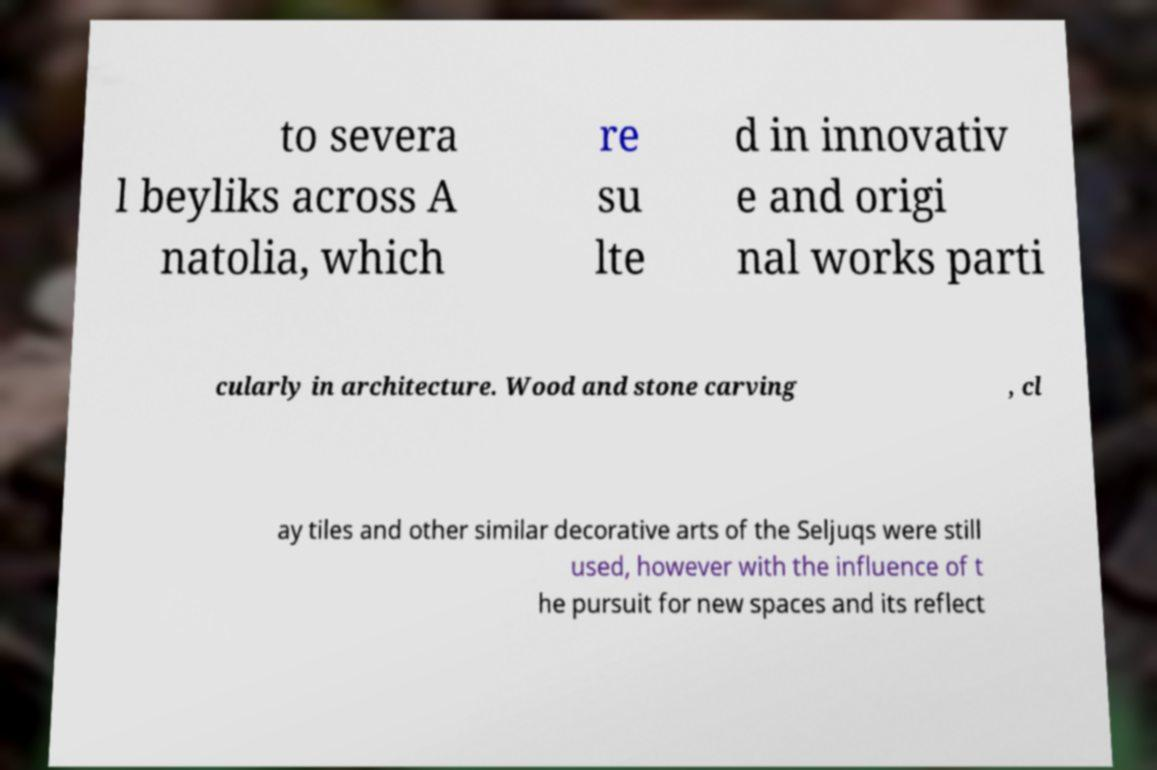Can you accurately transcribe the text from the provided image for me? to severa l beyliks across A natolia, which re su lte d in innovativ e and origi nal works parti cularly in architecture. Wood and stone carving , cl ay tiles and other similar decorative arts of the Seljuqs were still used, however with the influence of t he pursuit for new spaces and its reflect 